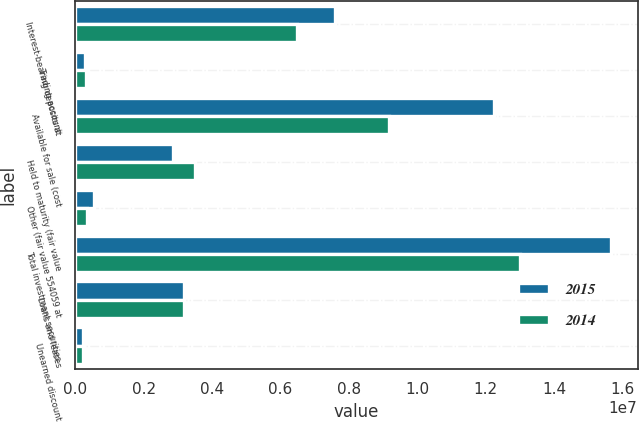<chart> <loc_0><loc_0><loc_500><loc_500><stacked_bar_chart><ecel><fcel>Interest-bearing deposits at<fcel>Trading account<fcel>Available for sale (cost<fcel>Held to maturity (fair value<fcel>Other (fair value 554059 at<fcel>Total investment securities<fcel>Loans and leases<fcel>Unearned discount<nl><fcel>2015<fcel>7.59435e+06<fcel>273783<fcel>1.22427e+07<fcel>2.85971e+06<fcel>554059<fcel>1.56564e+07<fcel>3.18379e+06<fcel>229735<nl><fcel>2014<fcel>6.47087e+06<fcel>308175<fcel>9.15693e+06<fcel>3.50787e+06<fcel>328742<fcel>1.29935e+07<fcel>3.18379e+06<fcel>230413<nl></chart> 